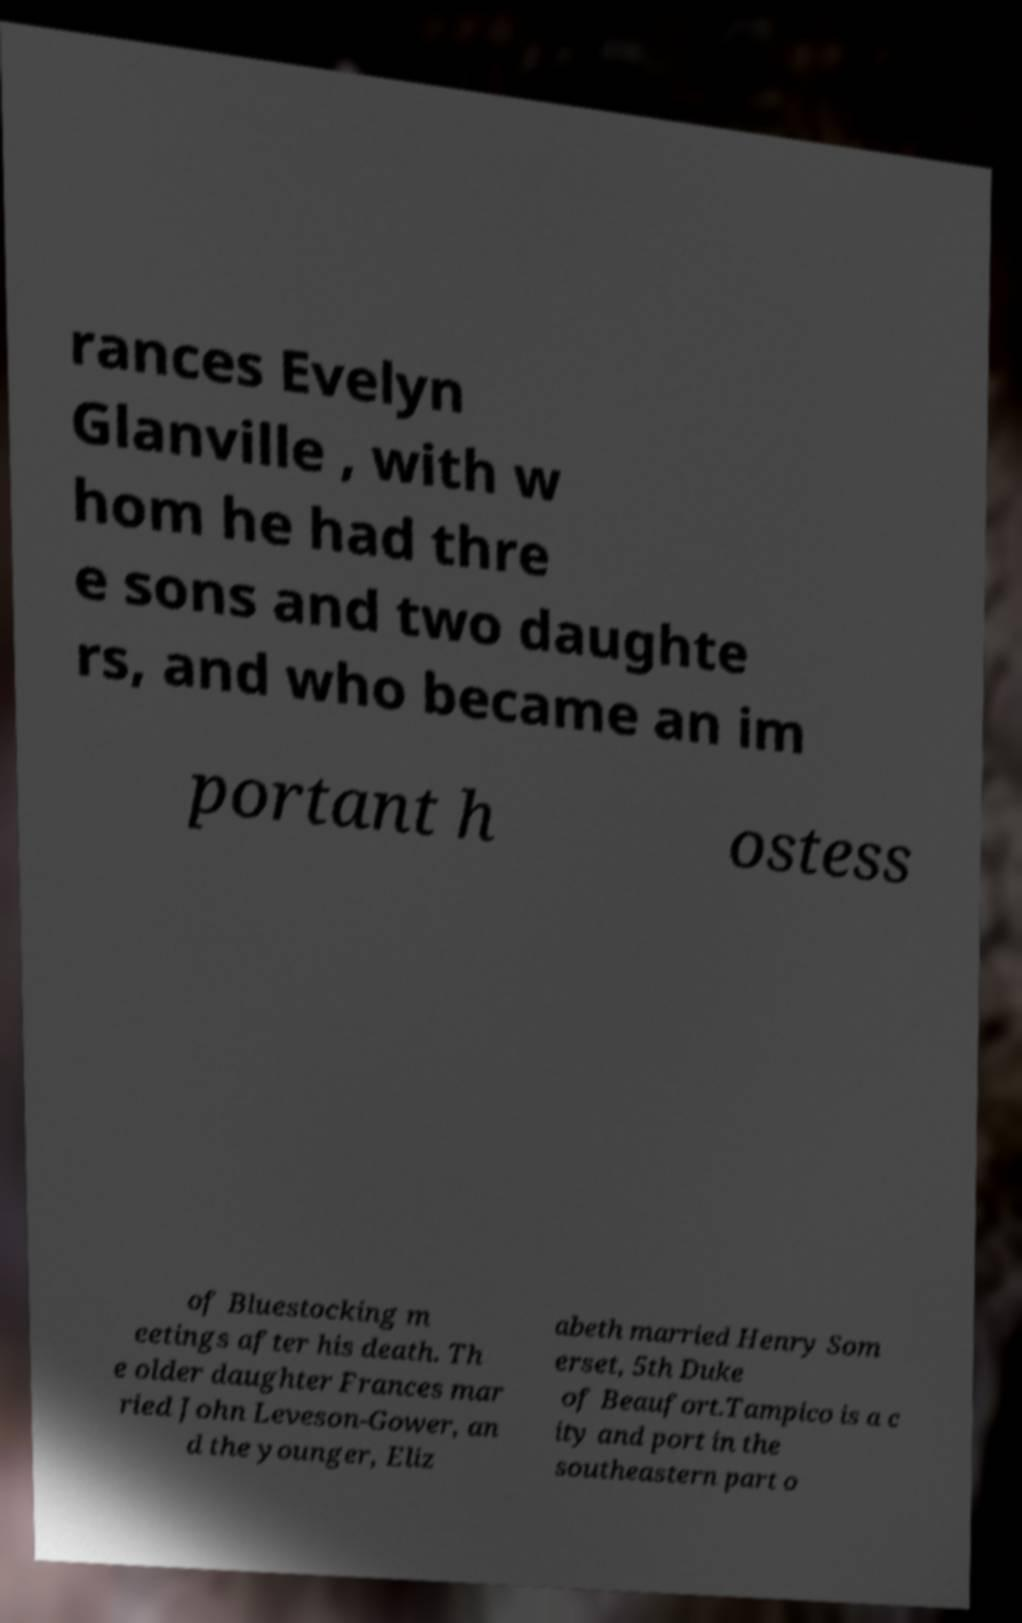Could you assist in decoding the text presented in this image and type it out clearly? rances Evelyn Glanville , with w hom he had thre e sons and two daughte rs, and who became an im portant h ostess of Bluestocking m eetings after his death. Th e older daughter Frances mar ried John Leveson-Gower, an d the younger, Eliz abeth married Henry Som erset, 5th Duke of Beaufort.Tampico is a c ity and port in the southeastern part o 